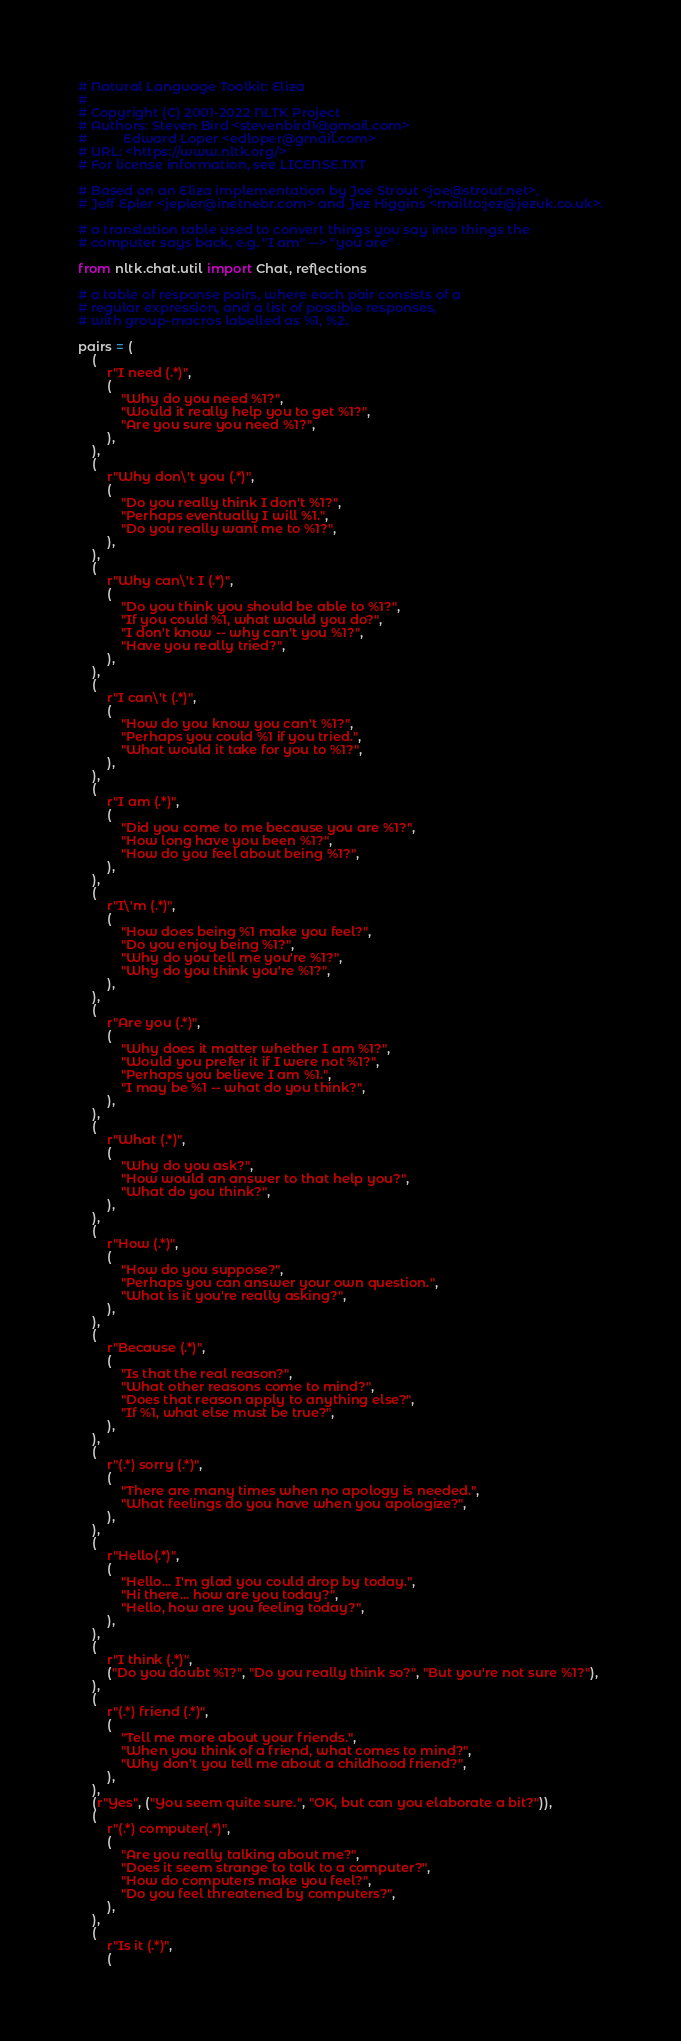<code> <loc_0><loc_0><loc_500><loc_500><_Python_># Natural Language Toolkit: Eliza
#
# Copyright (C) 2001-2022 NLTK Project
# Authors: Steven Bird <stevenbird1@gmail.com>
#          Edward Loper <edloper@gmail.com>
# URL: <https://www.nltk.org/>
# For license information, see LICENSE.TXT

# Based on an Eliza implementation by Joe Strout <joe@strout.net>,
# Jeff Epler <jepler@inetnebr.com> and Jez Higgins <mailto:jez@jezuk.co.uk>.

# a translation table used to convert things you say into things the
# computer says back, e.g. "I am" --> "you are"

from nltk.chat.util import Chat, reflections

# a table of response pairs, where each pair consists of a
# regular expression, and a list of possible responses,
# with group-macros labelled as %1, %2.

pairs = (
    (
        r"I need (.*)",
        (
            "Why do you need %1?",
            "Would it really help you to get %1?",
            "Are you sure you need %1?",
        ),
    ),
    (
        r"Why don\'t you (.*)",
        (
            "Do you really think I don't %1?",
            "Perhaps eventually I will %1.",
            "Do you really want me to %1?",
        ),
    ),
    (
        r"Why can\'t I (.*)",
        (
            "Do you think you should be able to %1?",
            "If you could %1, what would you do?",
            "I don't know -- why can't you %1?",
            "Have you really tried?",
        ),
    ),
    (
        r"I can\'t (.*)",
        (
            "How do you know you can't %1?",
            "Perhaps you could %1 if you tried.",
            "What would it take for you to %1?",
        ),
    ),
    (
        r"I am (.*)",
        (
            "Did you come to me because you are %1?",
            "How long have you been %1?",
            "How do you feel about being %1?",
        ),
    ),
    (
        r"I\'m (.*)",
        (
            "How does being %1 make you feel?",
            "Do you enjoy being %1?",
            "Why do you tell me you're %1?",
            "Why do you think you're %1?",
        ),
    ),
    (
        r"Are you (.*)",
        (
            "Why does it matter whether I am %1?",
            "Would you prefer it if I were not %1?",
            "Perhaps you believe I am %1.",
            "I may be %1 -- what do you think?",
        ),
    ),
    (
        r"What (.*)",
        (
            "Why do you ask?",
            "How would an answer to that help you?",
            "What do you think?",
        ),
    ),
    (
        r"How (.*)",
        (
            "How do you suppose?",
            "Perhaps you can answer your own question.",
            "What is it you're really asking?",
        ),
    ),
    (
        r"Because (.*)",
        (
            "Is that the real reason?",
            "What other reasons come to mind?",
            "Does that reason apply to anything else?",
            "If %1, what else must be true?",
        ),
    ),
    (
        r"(.*) sorry (.*)",
        (
            "There are many times when no apology is needed.",
            "What feelings do you have when you apologize?",
        ),
    ),
    (
        r"Hello(.*)",
        (
            "Hello... I'm glad you could drop by today.",
            "Hi there... how are you today?",
            "Hello, how are you feeling today?",
        ),
    ),
    (
        r"I think (.*)",
        ("Do you doubt %1?", "Do you really think so?", "But you're not sure %1?"),
    ),
    (
        r"(.*) friend (.*)",
        (
            "Tell me more about your friends.",
            "When you think of a friend, what comes to mind?",
            "Why don't you tell me about a childhood friend?",
        ),
    ),
    (r"Yes", ("You seem quite sure.", "OK, but can you elaborate a bit?")),
    (
        r"(.*) computer(.*)",
        (
            "Are you really talking about me?",
            "Does it seem strange to talk to a computer?",
            "How do computers make you feel?",
            "Do you feel threatened by computers?",
        ),
    ),
    (
        r"Is it (.*)",
        (</code> 